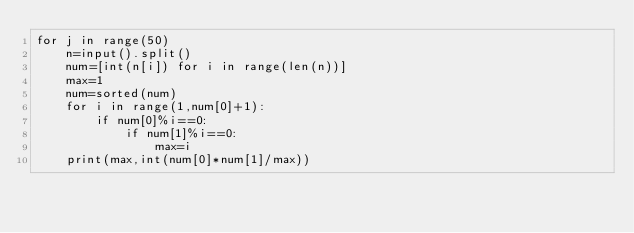<code> <loc_0><loc_0><loc_500><loc_500><_Python_>for j in range(50)
    n=input().split()
    num=[int(n[i]) for i in range(len(n))]
    max=1
    num=sorted(num)
    for i in range(1,num[0]+1):
        if num[0]%i==0:
            if num[1]%i==0:
                max=i
    print(max,int(num[0]*num[1]/max))</code> 